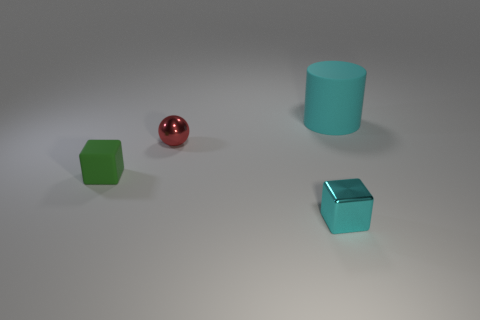How many other objects are there of the same material as the tiny red ball? Based on the image provided, the tiny red ball appears to have a shiny, smooth texture that is reflective, much like a polished material. Among the other objects in the image, one blue cube closely shares these visual properties and thus appears to be made of the same or a similar polished material. 